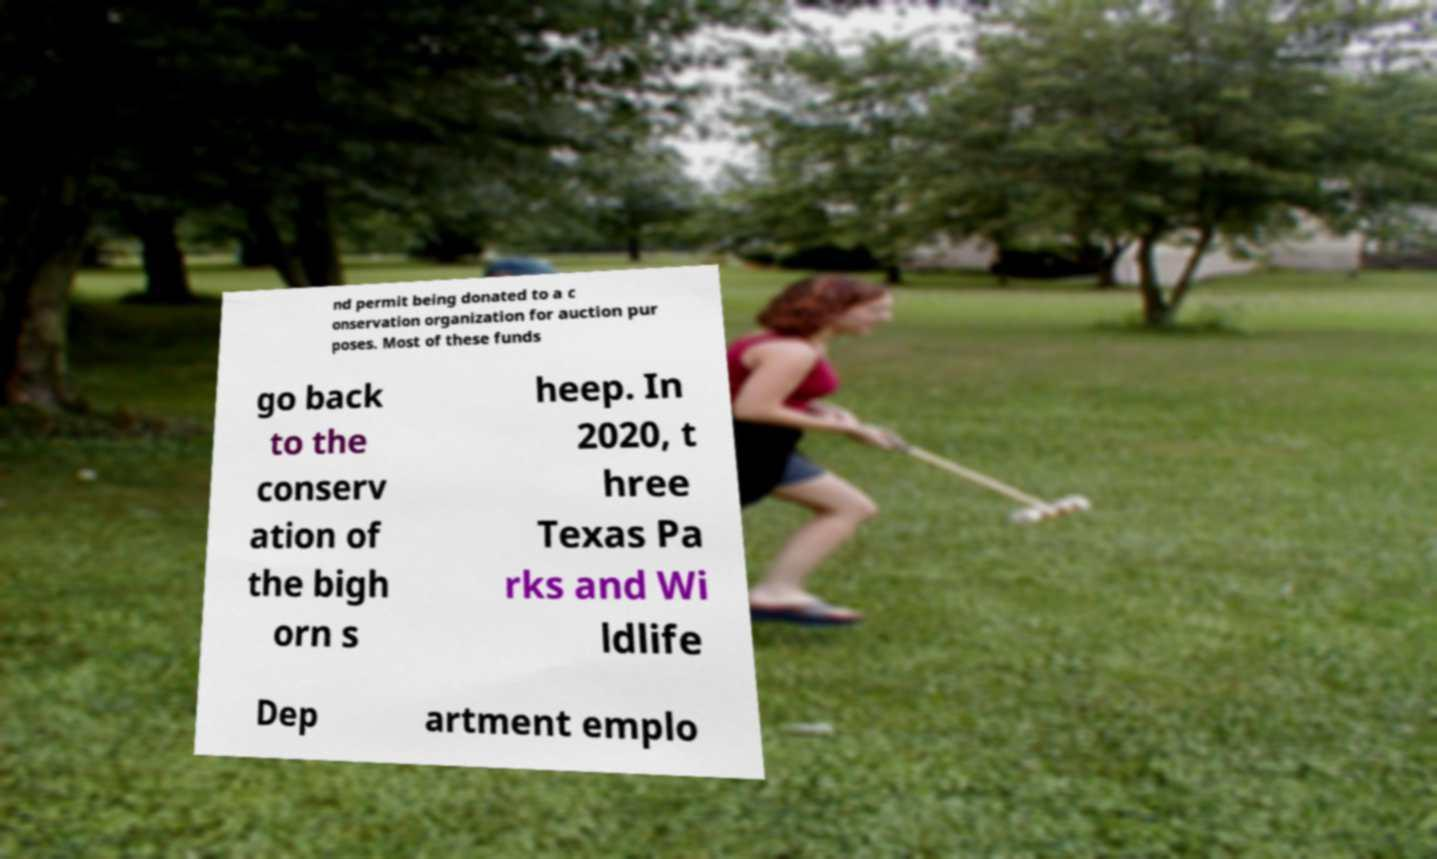Could you assist in decoding the text presented in this image and type it out clearly? nd permit being donated to a c onservation organization for auction pur poses. Most of these funds go back to the conserv ation of the bigh orn s heep. In 2020, t hree Texas Pa rks and Wi ldlife Dep artment emplo 